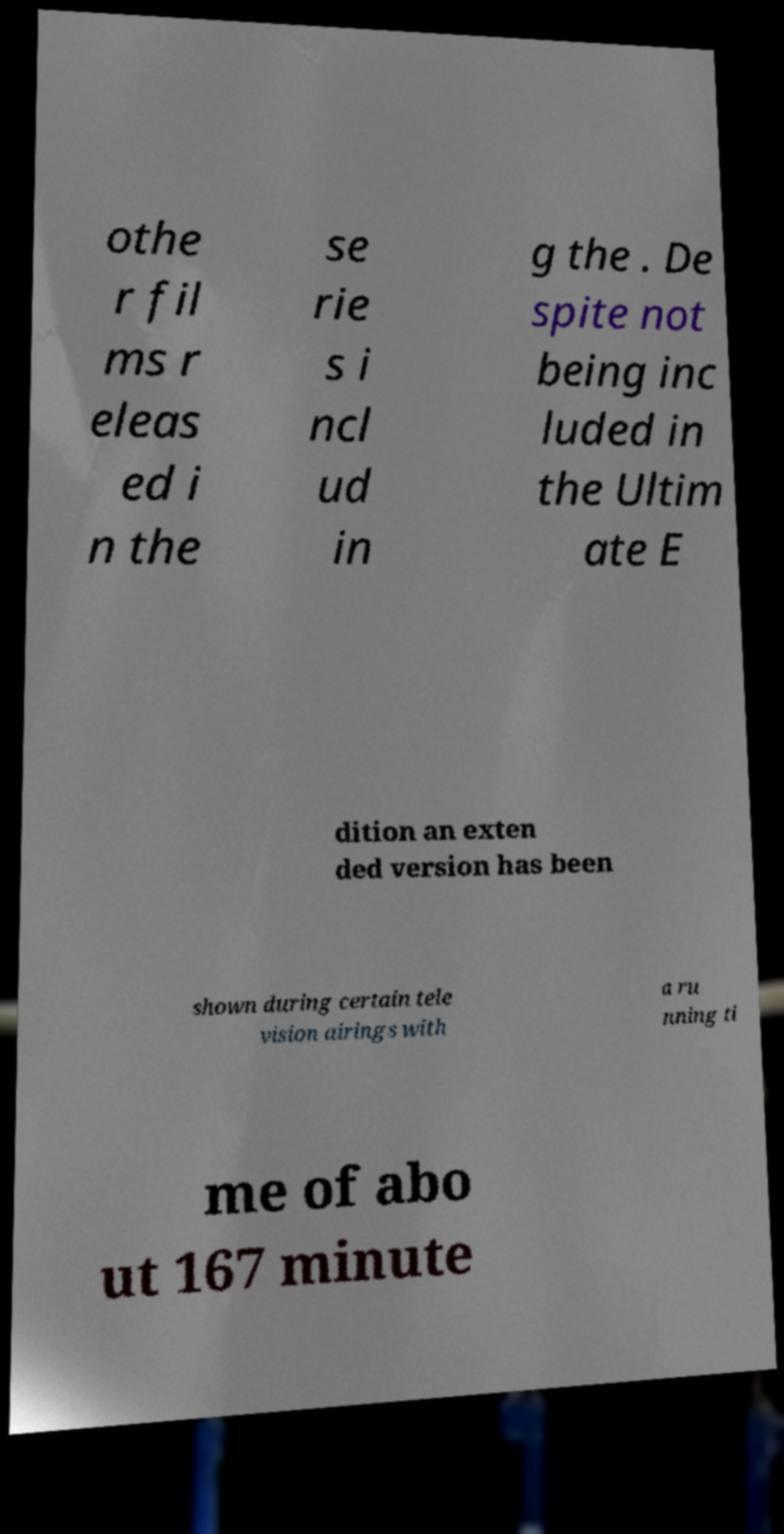Could you assist in decoding the text presented in this image and type it out clearly? othe r fil ms r eleas ed i n the se rie s i ncl ud in g the . De spite not being inc luded in the Ultim ate E dition an exten ded version has been shown during certain tele vision airings with a ru nning ti me of abo ut 167 minute 